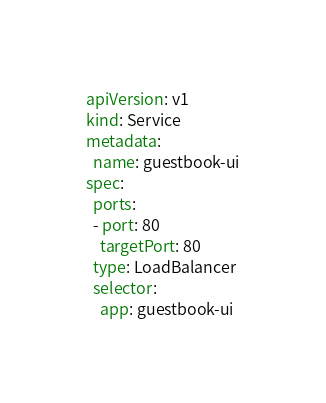Convert code to text. <code><loc_0><loc_0><loc_500><loc_500><_YAML_>apiVersion: v1
kind: Service
metadata:
  name: guestbook-ui
spec:
  ports:
  - port: 80
    targetPort: 80
  type: LoadBalancer
  selector:
    app: guestbook-ui
</code> 